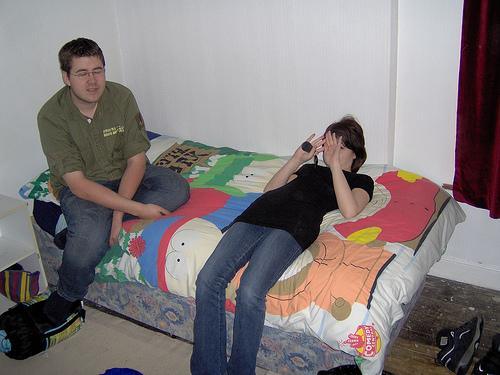Explain what the Comedy Central logo in the image looks like. The Comedy Central logo is rectangular with rounded edges and shows "Comedy" written above "Central." Mention the type of subject printed on the bed comforter. The bed comforter has a South Park design. List the items that are on the floor in the image. There are black and gray sneakers, a blue shirt, and a pair of blue jeans on the floor. Count the number of people on the bed and mention the color of their jeans. There are two people on the bed wearing blue jeans. Identify the type of shirt the man in the image is wearing. The man is wearing a green button-down shirt with rolled-up sleeves. What item does the girl in the image have in her hand? The girl is holding a pair of sunglasses in her hand. Name the type of shoes and color available on the floor in the image. There are black and gray sneakers on the floor. Describe the type of top the woman in the image is wearing. The woman is wearing a black short-sleeved top. Describe the position of the people on the bed. The boy is sitting on the bed with his eyes closed, while the girl is laying across the bed with her face hidden by her hands. What type of curtains is present in the image and what color are they? There are red window curtains in the image. If you look closely, you can see a bouquet of flowers on the bedside table next to the girl. Describe the different types of flowers you see. Can you locate a purple cat on top of the bed, lying beside the young man? The purple cat is wearing a sparkling collar. Identify the framed painting of a landscape on the wall above the bed. The painting depicts a beautiful sunset over the mountains. Spot the fancy chandelier hanging from the ceiling near the red window curtain. The chandelier has intricate gold details and crystal accents. Find an opened book with a yellow cover, laid flat on the floor near the blue shirt. What is the title of the book? Can you find the stuffed teddy bear wearing a blue bowtie, sitting by the black and gray shoes on the floor? The teddy bear has a warm, friendly smile on its face. 